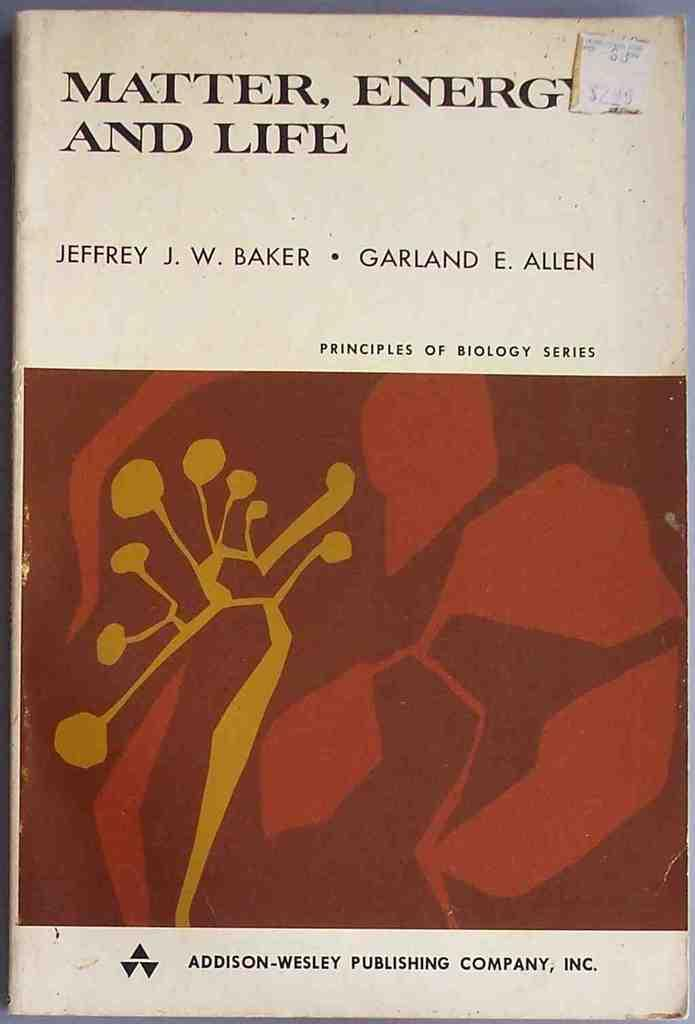Provide a one-sentence caption for the provided image. Matter, energy, and life book by Jeffrey J. W. Baker and Garland E. Allen. 